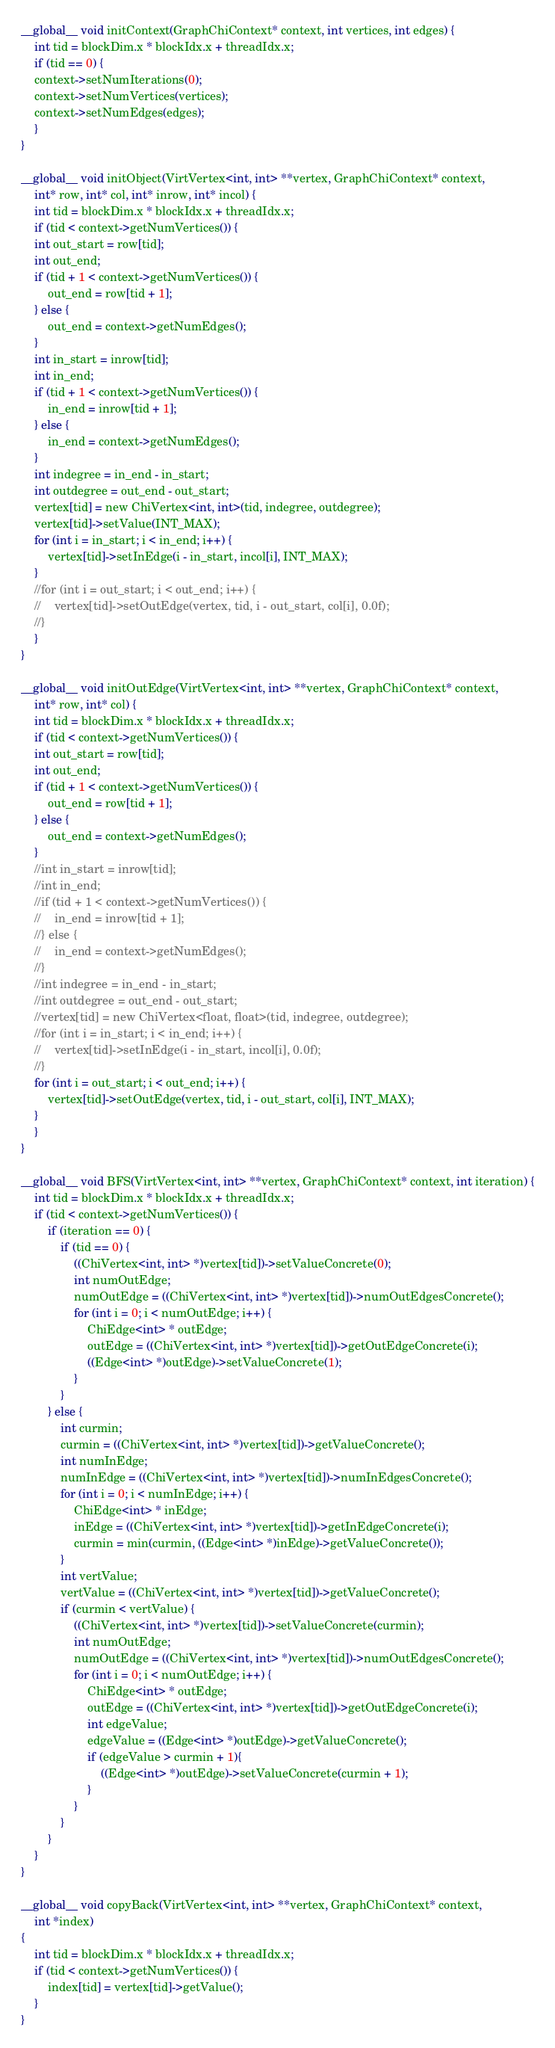Convert code to text. <code><loc_0><loc_0><loc_500><loc_500><_Cuda_>__global__ void initContext(GraphChiContext* context, int vertices, int edges) {
    int tid = blockDim.x * blockIdx.x + threadIdx.x;
    if (tid == 0) {
	context->setNumIterations(0);
	context->setNumVertices(vertices);
	context->setNumEdges(edges);
    }
}

__global__ void initObject(VirtVertex<int, int> **vertex, GraphChiContext* context,
	int* row, int* col, int* inrow, int* incol) {
    int tid = blockDim.x * blockIdx.x + threadIdx.x;
    if (tid < context->getNumVertices()) {
	int out_start = row[tid];
	int out_end;
	if (tid + 1 < context->getNumVertices()) {
	    out_end = row[tid + 1];
	} else {
	    out_end = context->getNumEdges();
	}
	int in_start = inrow[tid];
	int in_end;
	if (tid + 1 < context->getNumVertices()) {
	    in_end = inrow[tid + 1];
	} else {
	    in_end = context->getNumEdges();
	}
	int indegree = in_end - in_start;
	int outdegree = out_end - out_start;
	vertex[tid] = new ChiVertex<int, int>(tid, indegree, outdegree);
	vertex[tid]->setValue(INT_MAX);
	for (int i = in_start; i < in_end; i++) {
	    vertex[tid]->setInEdge(i - in_start, incol[i], INT_MAX);
	}
	//for (int i = out_start; i < out_end; i++) {
	//    vertex[tid]->setOutEdge(vertex, tid, i - out_start, col[i], 0.0f);
	//}
    }
}

__global__ void initOutEdge(VirtVertex<int, int> **vertex, GraphChiContext* context,
	int* row, int* col) {
    int tid = blockDim.x * blockIdx.x + threadIdx.x;
    if (tid < context->getNumVertices()) {
	int out_start = row[tid];
	int out_end;
	if (tid + 1 < context->getNumVertices()) {
	    out_end = row[tid + 1];
	} else {
	    out_end = context->getNumEdges();
	}
	//int in_start = inrow[tid];
	//int in_end;
	//if (tid + 1 < context->getNumVertices()) {
	//    in_end = inrow[tid + 1];
	//} else {
	//    in_end = context->getNumEdges();
	//}
	//int indegree = in_end - in_start;
	//int outdegree = out_end - out_start;
	//vertex[tid] = new ChiVertex<float, float>(tid, indegree, outdegree);
	//for (int i = in_start; i < in_end; i++) {
	//    vertex[tid]->setInEdge(i - in_start, incol[i], 0.0f);
	//}
	for (int i = out_start; i < out_end; i++) {
	    vertex[tid]->setOutEdge(vertex, tid, i - out_start, col[i], INT_MAX);
	}
    }
}

__global__ void BFS(VirtVertex<int, int> **vertex, GraphChiContext* context, int iteration) {
    int tid = blockDim.x * blockIdx.x + threadIdx.x;
    if (tid < context->getNumVertices()) {
        if (iteration == 0) {
            if (tid == 0) {
                ((ChiVertex<int, int> *)vertex[tid])->setValueConcrete(0);
                int numOutEdge;
                numOutEdge = ((ChiVertex<int, int> *)vertex[tid])->numOutEdgesConcrete();
                for (int i = 0; i < numOutEdge; i++) {
                    ChiEdge<int> * outEdge;
                    outEdge = ((ChiVertex<int, int> *)vertex[tid])->getOutEdgeConcrete(i);
                    ((Edge<int> *)outEdge)->setValueConcrete(1);
                }
            }
        } else {
            int curmin;
            curmin = ((ChiVertex<int, int> *)vertex[tid])->getValueConcrete();
            int numInEdge;
            numInEdge = ((ChiVertex<int, int> *)vertex[tid])->numInEdgesConcrete();
            for (int i = 0; i < numInEdge; i++) {
                ChiEdge<int> * inEdge;
                inEdge = ((ChiVertex<int, int> *)vertex[tid])->getInEdgeConcrete(i);
                curmin = min(curmin, ((Edge<int> *)inEdge)->getValueConcrete());
            }
            int vertValue;
            vertValue = ((ChiVertex<int, int> *)vertex[tid])->getValueConcrete();
            if (curmin < vertValue) {
                ((ChiVertex<int, int> *)vertex[tid])->setValueConcrete(curmin);
                int numOutEdge;
                numOutEdge = ((ChiVertex<int, int> *)vertex[tid])->numOutEdgesConcrete();
                for (int i = 0; i < numOutEdge; i++) {
                    ChiEdge<int> * outEdge;
                    outEdge = ((ChiVertex<int, int> *)vertex[tid])->getOutEdgeConcrete(i);
                    int edgeValue;
                    edgeValue = ((Edge<int> *)outEdge)->getValueConcrete();
                    if (edgeValue > curmin + 1){
                        ((Edge<int> *)outEdge)->setValueConcrete(curmin + 1);
                    }
                }
            }
        }
    }
}

__global__ void copyBack(VirtVertex<int, int> **vertex, GraphChiContext* context,
	int *index)
{
    int tid = blockDim.x * blockIdx.x + threadIdx.x;
    if (tid < context->getNumVertices()) {
        index[tid] = vertex[tid]->getValue();
    }
}
</code> 